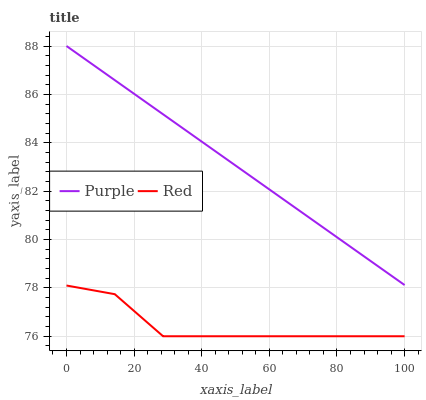Does Red have the minimum area under the curve?
Answer yes or no. Yes. Does Purple have the maximum area under the curve?
Answer yes or no. Yes. Does Red have the maximum area under the curve?
Answer yes or no. No. Is Purple the smoothest?
Answer yes or no. Yes. Is Red the roughest?
Answer yes or no. Yes. Is Red the smoothest?
Answer yes or no. No. Does Red have the lowest value?
Answer yes or no. Yes. Does Purple have the highest value?
Answer yes or no. Yes. Does Red have the highest value?
Answer yes or no. No. Is Red less than Purple?
Answer yes or no. Yes. Is Purple greater than Red?
Answer yes or no. Yes. Does Red intersect Purple?
Answer yes or no. No. 